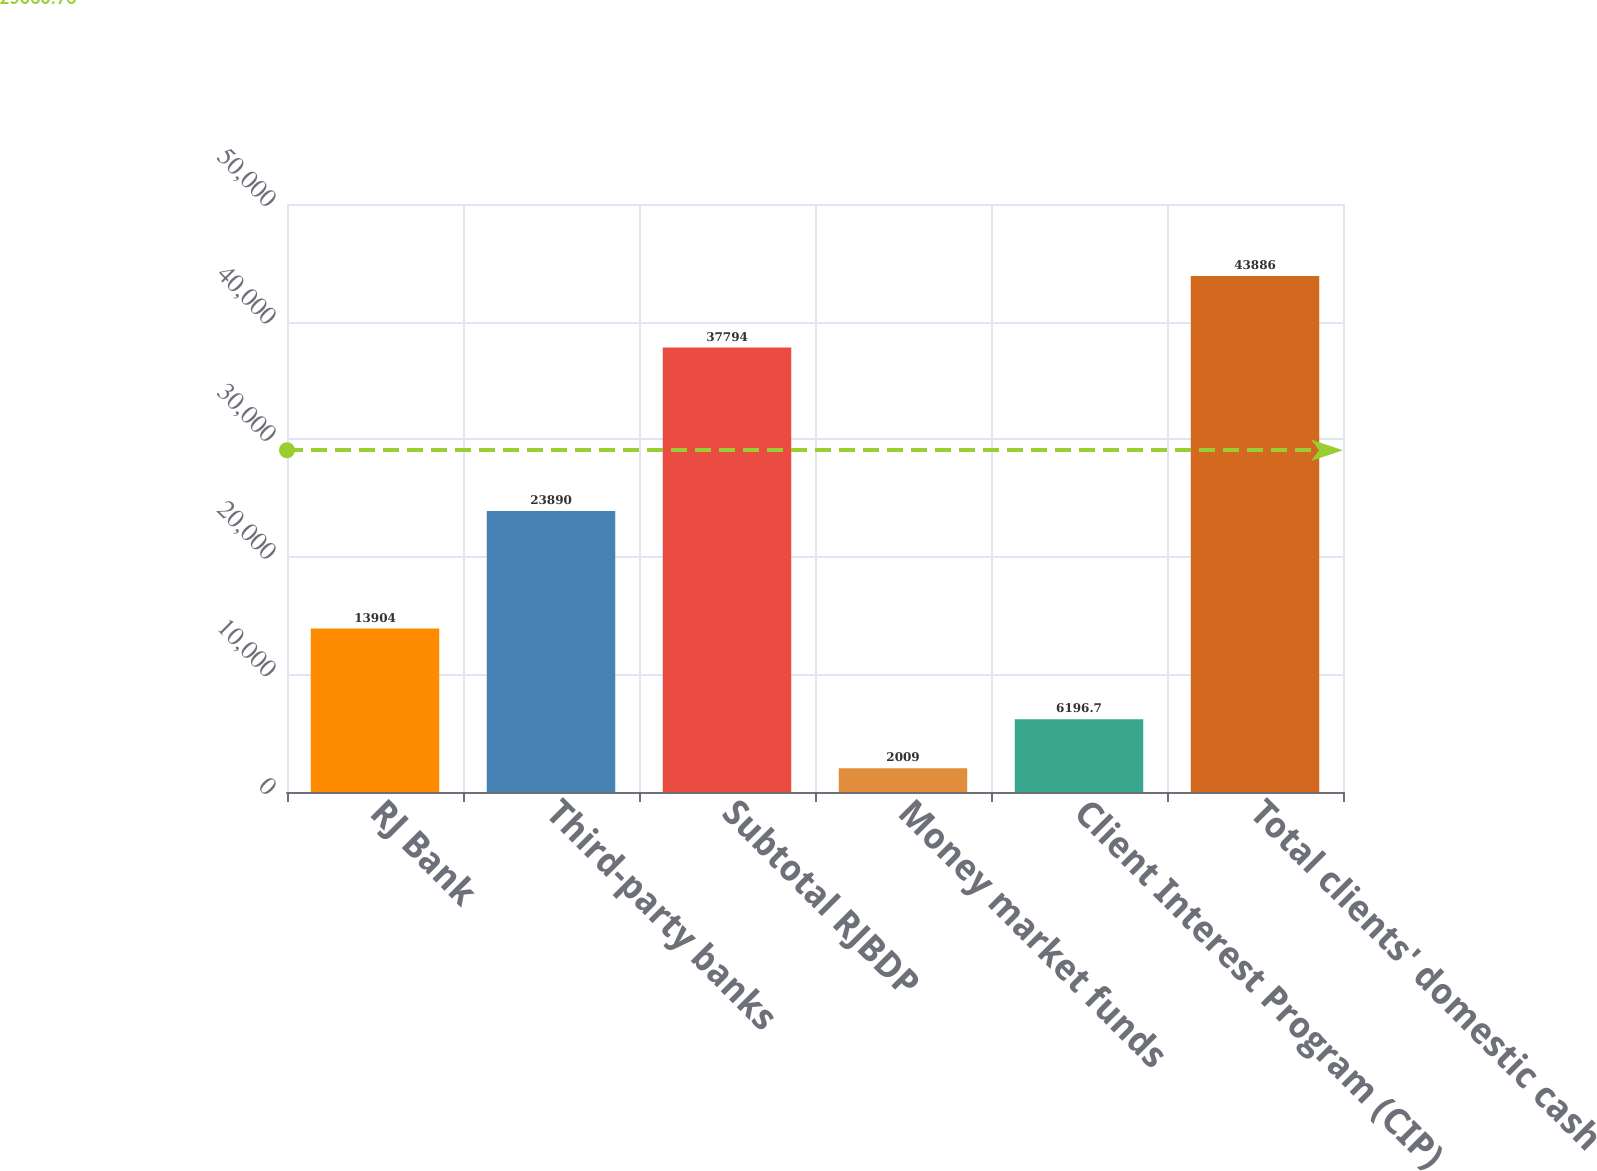Convert chart. <chart><loc_0><loc_0><loc_500><loc_500><bar_chart><fcel>RJ Bank<fcel>Third-party banks<fcel>Subtotal RJBDP<fcel>Money market funds<fcel>Client Interest Program (CIP)<fcel>Total clients' domestic cash<nl><fcel>13904<fcel>23890<fcel>37794<fcel>2009<fcel>6196.7<fcel>43886<nl></chart> 